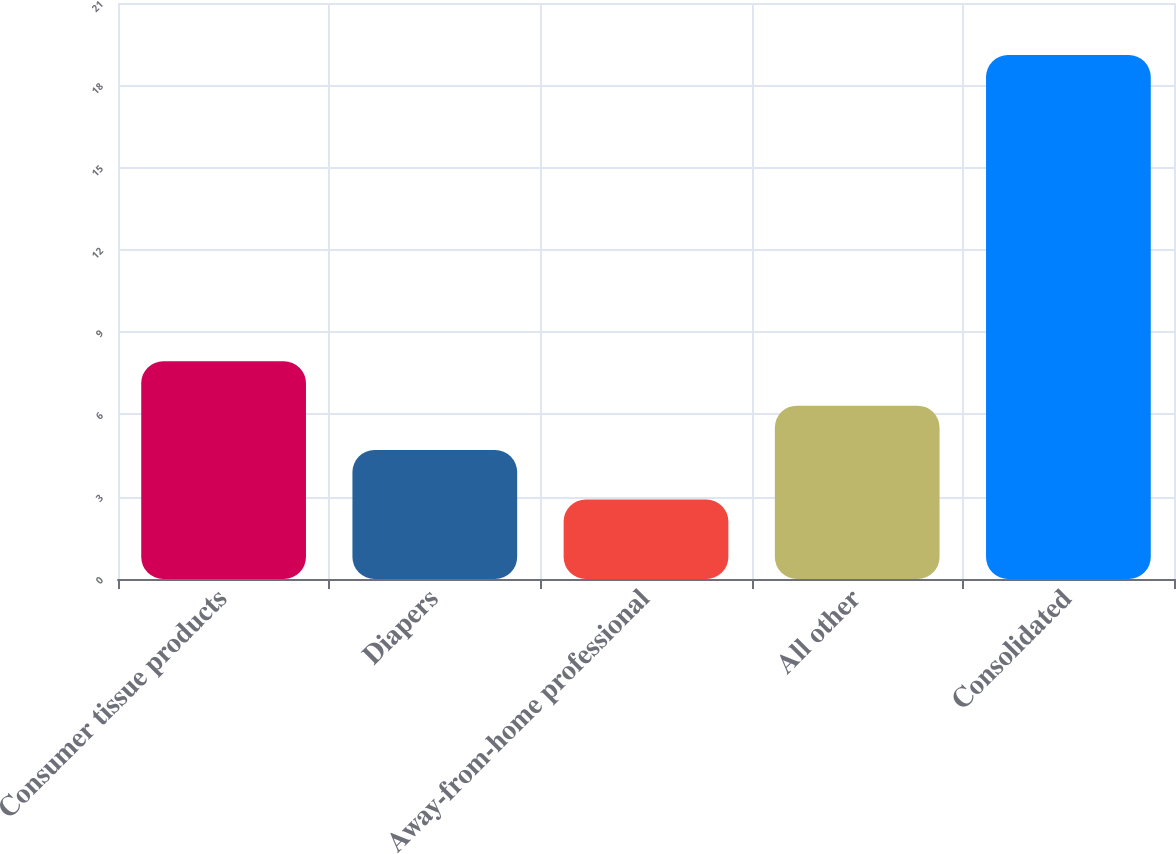Convert chart. <chart><loc_0><loc_0><loc_500><loc_500><bar_chart><fcel>Consumer tissue products<fcel>Diapers<fcel>Away-from-home professional<fcel>All other<fcel>Consolidated<nl><fcel>7.94<fcel>4.7<fcel>2.9<fcel>6.32<fcel>19.1<nl></chart> 